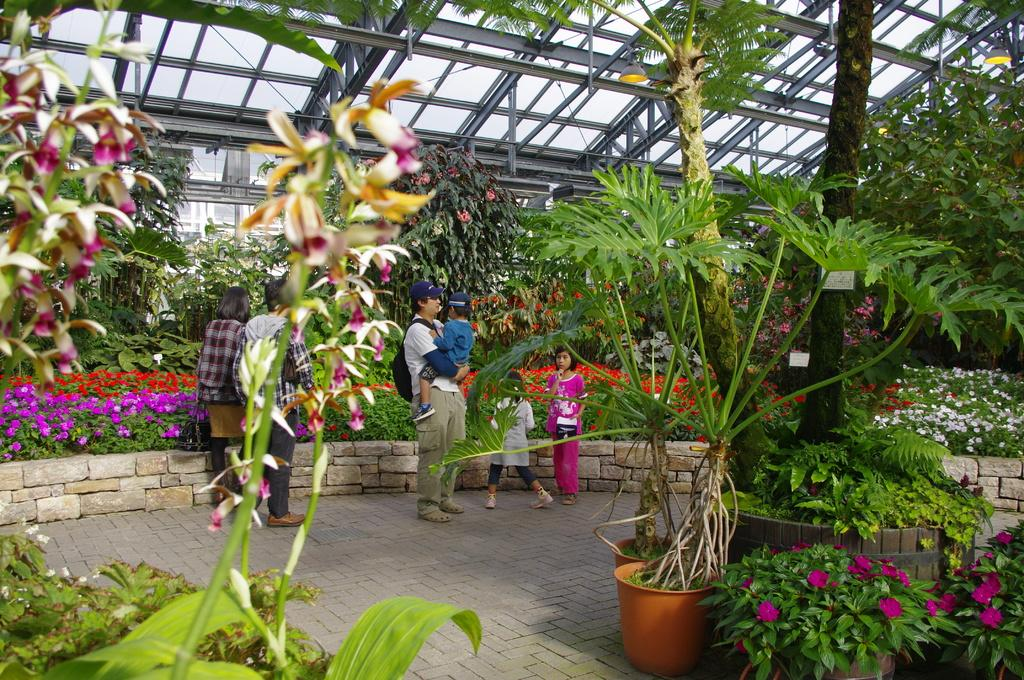Where are the people located in the image? There are people under the shed in the image. What else can be found under the shed? There are plants under the shed, and the plants have flowers. What is the man wearing in the image? The man is wearing a bag in the image. What is the man doing with the baby? The man is carrying a baby in the image. Can you tell me how many times the baby has been bitten by a needle in the image? There is no mention of a baby being bitten by a needle in the image, so it cannot be determined. 